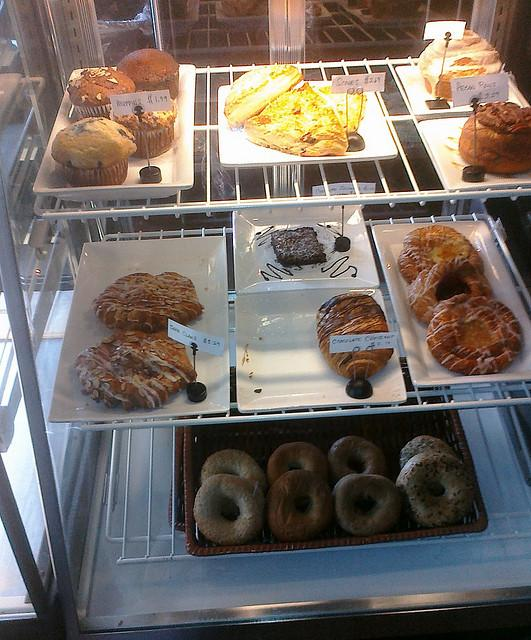What type of Danish is in the middle of the other two?

Choices:
A) cheese
B) peach
C) strawberry
D) blueberry blueberry 